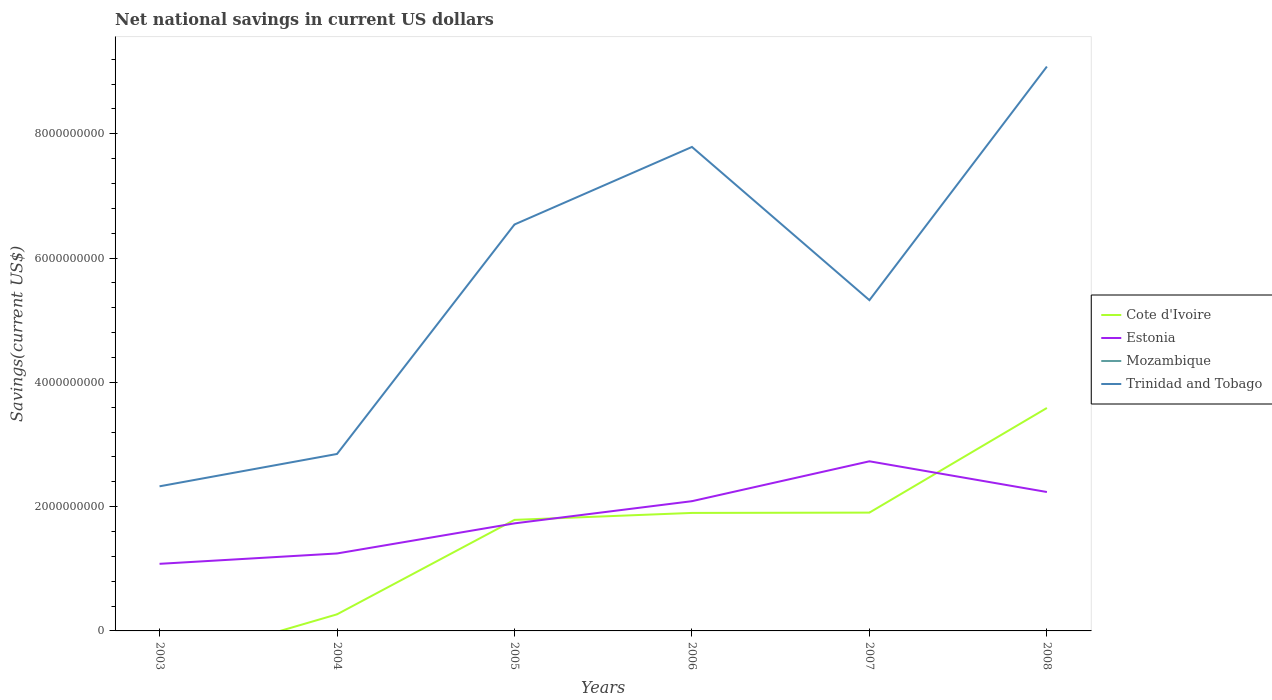How many different coloured lines are there?
Make the answer very short. 3. Does the line corresponding to Trinidad and Tobago intersect with the line corresponding to Cote d'Ivoire?
Give a very brief answer. No. Is the number of lines equal to the number of legend labels?
Provide a succinct answer. No. Across all years, what is the maximum net national savings in Mozambique?
Offer a very short reply. 0. What is the total net national savings in Cote d'Ivoire in the graph?
Ensure brevity in your answer.  -1.63e+09. What is the difference between the highest and the second highest net national savings in Estonia?
Provide a short and direct response. 1.65e+09. Is the net national savings in Trinidad and Tobago strictly greater than the net national savings in Mozambique over the years?
Make the answer very short. No. How many years are there in the graph?
Keep it short and to the point. 6. What is the difference between two consecutive major ticks on the Y-axis?
Keep it short and to the point. 2.00e+09. Does the graph contain grids?
Provide a short and direct response. No. Where does the legend appear in the graph?
Offer a very short reply. Center right. How many legend labels are there?
Give a very brief answer. 4. How are the legend labels stacked?
Provide a short and direct response. Vertical. What is the title of the graph?
Your answer should be very brief. Net national savings in current US dollars. What is the label or title of the Y-axis?
Provide a succinct answer. Savings(current US$). What is the Savings(current US$) of Estonia in 2003?
Ensure brevity in your answer.  1.08e+09. What is the Savings(current US$) of Trinidad and Tobago in 2003?
Provide a succinct answer. 2.33e+09. What is the Savings(current US$) of Cote d'Ivoire in 2004?
Your answer should be very brief. 2.67e+08. What is the Savings(current US$) in Estonia in 2004?
Give a very brief answer. 1.25e+09. What is the Savings(current US$) of Trinidad and Tobago in 2004?
Keep it short and to the point. 2.85e+09. What is the Savings(current US$) of Cote d'Ivoire in 2005?
Keep it short and to the point. 1.79e+09. What is the Savings(current US$) in Estonia in 2005?
Make the answer very short. 1.73e+09. What is the Savings(current US$) in Trinidad and Tobago in 2005?
Offer a very short reply. 6.54e+09. What is the Savings(current US$) in Cote d'Ivoire in 2006?
Make the answer very short. 1.90e+09. What is the Savings(current US$) of Estonia in 2006?
Provide a succinct answer. 2.09e+09. What is the Savings(current US$) of Mozambique in 2006?
Your answer should be very brief. 0. What is the Savings(current US$) of Trinidad and Tobago in 2006?
Your answer should be very brief. 7.79e+09. What is the Savings(current US$) of Cote d'Ivoire in 2007?
Ensure brevity in your answer.  1.90e+09. What is the Savings(current US$) in Estonia in 2007?
Your answer should be compact. 2.73e+09. What is the Savings(current US$) in Trinidad and Tobago in 2007?
Your response must be concise. 5.32e+09. What is the Savings(current US$) in Cote d'Ivoire in 2008?
Offer a very short reply. 3.59e+09. What is the Savings(current US$) in Estonia in 2008?
Offer a very short reply. 2.24e+09. What is the Savings(current US$) of Mozambique in 2008?
Your answer should be compact. 0. What is the Savings(current US$) of Trinidad and Tobago in 2008?
Give a very brief answer. 9.08e+09. Across all years, what is the maximum Savings(current US$) of Cote d'Ivoire?
Your response must be concise. 3.59e+09. Across all years, what is the maximum Savings(current US$) of Estonia?
Provide a short and direct response. 2.73e+09. Across all years, what is the maximum Savings(current US$) of Trinidad and Tobago?
Offer a very short reply. 9.08e+09. Across all years, what is the minimum Savings(current US$) in Cote d'Ivoire?
Ensure brevity in your answer.  0. Across all years, what is the minimum Savings(current US$) of Estonia?
Your answer should be compact. 1.08e+09. Across all years, what is the minimum Savings(current US$) in Trinidad and Tobago?
Provide a short and direct response. 2.33e+09. What is the total Savings(current US$) in Cote d'Ivoire in the graph?
Offer a very short reply. 9.45e+09. What is the total Savings(current US$) in Estonia in the graph?
Your answer should be compact. 1.11e+1. What is the total Savings(current US$) of Trinidad and Tobago in the graph?
Ensure brevity in your answer.  3.39e+1. What is the difference between the Savings(current US$) of Estonia in 2003 and that in 2004?
Make the answer very short. -1.67e+08. What is the difference between the Savings(current US$) of Trinidad and Tobago in 2003 and that in 2004?
Offer a terse response. -5.20e+08. What is the difference between the Savings(current US$) in Estonia in 2003 and that in 2005?
Give a very brief answer. -6.51e+08. What is the difference between the Savings(current US$) of Trinidad and Tobago in 2003 and that in 2005?
Your response must be concise. -4.21e+09. What is the difference between the Savings(current US$) in Estonia in 2003 and that in 2006?
Provide a short and direct response. -1.01e+09. What is the difference between the Savings(current US$) of Trinidad and Tobago in 2003 and that in 2006?
Make the answer very short. -5.46e+09. What is the difference between the Savings(current US$) of Estonia in 2003 and that in 2007?
Your response must be concise. -1.65e+09. What is the difference between the Savings(current US$) of Trinidad and Tobago in 2003 and that in 2007?
Your answer should be compact. -3.00e+09. What is the difference between the Savings(current US$) of Estonia in 2003 and that in 2008?
Offer a very short reply. -1.16e+09. What is the difference between the Savings(current US$) of Trinidad and Tobago in 2003 and that in 2008?
Ensure brevity in your answer.  -6.76e+09. What is the difference between the Savings(current US$) of Cote d'Ivoire in 2004 and that in 2005?
Your answer should be compact. -1.52e+09. What is the difference between the Savings(current US$) in Estonia in 2004 and that in 2005?
Offer a very short reply. -4.84e+08. What is the difference between the Savings(current US$) in Trinidad and Tobago in 2004 and that in 2005?
Keep it short and to the point. -3.69e+09. What is the difference between the Savings(current US$) of Cote d'Ivoire in 2004 and that in 2006?
Provide a succinct answer. -1.63e+09. What is the difference between the Savings(current US$) of Estonia in 2004 and that in 2006?
Ensure brevity in your answer.  -8.41e+08. What is the difference between the Savings(current US$) of Trinidad and Tobago in 2004 and that in 2006?
Your response must be concise. -4.94e+09. What is the difference between the Savings(current US$) in Cote d'Ivoire in 2004 and that in 2007?
Give a very brief answer. -1.64e+09. What is the difference between the Savings(current US$) in Estonia in 2004 and that in 2007?
Your answer should be very brief. -1.48e+09. What is the difference between the Savings(current US$) in Trinidad and Tobago in 2004 and that in 2007?
Make the answer very short. -2.48e+09. What is the difference between the Savings(current US$) in Cote d'Ivoire in 2004 and that in 2008?
Offer a very short reply. -3.32e+09. What is the difference between the Savings(current US$) in Estonia in 2004 and that in 2008?
Make the answer very short. -9.89e+08. What is the difference between the Savings(current US$) in Trinidad and Tobago in 2004 and that in 2008?
Offer a very short reply. -6.23e+09. What is the difference between the Savings(current US$) in Cote d'Ivoire in 2005 and that in 2006?
Your response must be concise. -1.12e+08. What is the difference between the Savings(current US$) of Estonia in 2005 and that in 2006?
Your answer should be compact. -3.57e+08. What is the difference between the Savings(current US$) in Trinidad and Tobago in 2005 and that in 2006?
Keep it short and to the point. -1.25e+09. What is the difference between the Savings(current US$) of Cote d'Ivoire in 2005 and that in 2007?
Provide a short and direct response. -1.17e+08. What is the difference between the Savings(current US$) of Estonia in 2005 and that in 2007?
Make the answer very short. -9.99e+08. What is the difference between the Savings(current US$) in Trinidad and Tobago in 2005 and that in 2007?
Ensure brevity in your answer.  1.22e+09. What is the difference between the Savings(current US$) in Cote d'Ivoire in 2005 and that in 2008?
Provide a succinct answer. -1.80e+09. What is the difference between the Savings(current US$) of Estonia in 2005 and that in 2008?
Offer a very short reply. -5.05e+08. What is the difference between the Savings(current US$) in Trinidad and Tobago in 2005 and that in 2008?
Offer a terse response. -2.54e+09. What is the difference between the Savings(current US$) of Cote d'Ivoire in 2006 and that in 2007?
Give a very brief answer. -4.95e+06. What is the difference between the Savings(current US$) in Estonia in 2006 and that in 2007?
Offer a very short reply. -6.42e+08. What is the difference between the Savings(current US$) in Trinidad and Tobago in 2006 and that in 2007?
Give a very brief answer. 2.47e+09. What is the difference between the Savings(current US$) in Cote d'Ivoire in 2006 and that in 2008?
Offer a terse response. -1.69e+09. What is the difference between the Savings(current US$) in Estonia in 2006 and that in 2008?
Make the answer very short. -1.48e+08. What is the difference between the Savings(current US$) in Trinidad and Tobago in 2006 and that in 2008?
Ensure brevity in your answer.  -1.29e+09. What is the difference between the Savings(current US$) of Cote d'Ivoire in 2007 and that in 2008?
Your answer should be compact. -1.68e+09. What is the difference between the Savings(current US$) in Estonia in 2007 and that in 2008?
Your answer should be very brief. 4.94e+08. What is the difference between the Savings(current US$) in Trinidad and Tobago in 2007 and that in 2008?
Keep it short and to the point. -3.76e+09. What is the difference between the Savings(current US$) in Estonia in 2003 and the Savings(current US$) in Trinidad and Tobago in 2004?
Give a very brief answer. -1.77e+09. What is the difference between the Savings(current US$) of Estonia in 2003 and the Savings(current US$) of Trinidad and Tobago in 2005?
Give a very brief answer. -5.46e+09. What is the difference between the Savings(current US$) in Estonia in 2003 and the Savings(current US$) in Trinidad and Tobago in 2006?
Your answer should be compact. -6.71e+09. What is the difference between the Savings(current US$) of Estonia in 2003 and the Savings(current US$) of Trinidad and Tobago in 2007?
Your answer should be very brief. -4.24e+09. What is the difference between the Savings(current US$) in Estonia in 2003 and the Savings(current US$) in Trinidad and Tobago in 2008?
Your answer should be very brief. -8.00e+09. What is the difference between the Savings(current US$) of Cote d'Ivoire in 2004 and the Savings(current US$) of Estonia in 2005?
Offer a very short reply. -1.46e+09. What is the difference between the Savings(current US$) in Cote d'Ivoire in 2004 and the Savings(current US$) in Trinidad and Tobago in 2005?
Give a very brief answer. -6.27e+09. What is the difference between the Savings(current US$) in Estonia in 2004 and the Savings(current US$) in Trinidad and Tobago in 2005?
Provide a short and direct response. -5.29e+09. What is the difference between the Savings(current US$) of Cote d'Ivoire in 2004 and the Savings(current US$) of Estonia in 2006?
Offer a terse response. -1.82e+09. What is the difference between the Savings(current US$) of Cote d'Ivoire in 2004 and the Savings(current US$) of Trinidad and Tobago in 2006?
Provide a succinct answer. -7.52e+09. What is the difference between the Savings(current US$) of Estonia in 2004 and the Savings(current US$) of Trinidad and Tobago in 2006?
Your answer should be very brief. -6.54e+09. What is the difference between the Savings(current US$) of Cote d'Ivoire in 2004 and the Savings(current US$) of Estonia in 2007?
Your response must be concise. -2.46e+09. What is the difference between the Savings(current US$) of Cote d'Ivoire in 2004 and the Savings(current US$) of Trinidad and Tobago in 2007?
Offer a terse response. -5.06e+09. What is the difference between the Savings(current US$) in Estonia in 2004 and the Savings(current US$) in Trinidad and Tobago in 2007?
Offer a terse response. -4.08e+09. What is the difference between the Savings(current US$) in Cote d'Ivoire in 2004 and the Savings(current US$) in Estonia in 2008?
Provide a succinct answer. -1.97e+09. What is the difference between the Savings(current US$) in Cote d'Ivoire in 2004 and the Savings(current US$) in Trinidad and Tobago in 2008?
Provide a short and direct response. -8.82e+09. What is the difference between the Savings(current US$) in Estonia in 2004 and the Savings(current US$) in Trinidad and Tobago in 2008?
Offer a very short reply. -7.84e+09. What is the difference between the Savings(current US$) of Cote d'Ivoire in 2005 and the Savings(current US$) of Estonia in 2006?
Offer a very short reply. -3.01e+08. What is the difference between the Savings(current US$) in Cote d'Ivoire in 2005 and the Savings(current US$) in Trinidad and Tobago in 2006?
Make the answer very short. -6.00e+09. What is the difference between the Savings(current US$) of Estonia in 2005 and the Savings(current US$) of Trinidad and Tobago in 2006?
Your response must be concise. -6.06e+09. What is the difference between the Savings(current US$) in Cote d'Ivoire in 2005 and the Savings(current US$) in Estonia in 2007?
Ensure brevity in your answer.  -9.43e+08. What is the difference between the Savings(current US$) in Cote d'Ivoire in 2005 and the Savings(current US$) in Trinidad and Tobago in 2007?
Provide a succinct answer. -3.54e+09. What is the difference between the Savings(current US$) of Estonia in 2005 and the Savings(current US$) of Trinidad and Tobago in 2007?
Offer a very short reply. -3.59e+09. What is the difference between the Savings(current US$) in Cote d'Ivoire in 2005 and the Savings(current US$) in Estonia in 2008?
Give a very brief answer. -4.48e+08. What is the difference between the Savings(current US$) in Cote d'Ivoire in 2005 and the Savings(current US$) in Trinidad and Tobago in 2008?
Your answer should be very brief. -7.30e+09. What is the difference between the Savings(current US$) in Estonia in 2005 and the Savings(current US$) in Trinidad and Tobago in 2008?
Give a very brief answer. -7.35e+09. What is the difference between the Savings(current US$) of Cote d'Ivoire in 2006 and the Savings(current US$) of Estonia in 2007?
Keep it short and to the point. -8.31e+08. What is the difference between the Savings(current US$) of Cote d'Ivoire in 2006 and the Savings(current US$) of Trinidad and Tobago in 2007?
Ensure brevity in your answer.  -3.42e+09. What is the difference between the Savings(current US$) of Estonia in 2006 and the Savings(current US$) of Trinidad and Tobago in 2007?
Your answer should be very brief. -3.24e+09. What is the difference between the Savings(current US$) of Cote d'Ivoire in 2006 and the Savings(current US$) of Estonia in 2008?
Your answer should be compact. -3.37e+08. What is the difference between the Savings(current US$) in Cote d'Ivoire in 2006 and the Savings(current US$) in Trinidad and Tobago in 2008?
Ensure brevity in your answer.  -7.18e+09. What is the difference between the Savings(current US$) in Estonia in 2006 and the Savings(current US$) in Trinidad and Tobago in 2008?
Provide a short and direct response. -6.99e+09. What is the difference between the Savings(current US$) of Cote d'Ivoire in 2007 and the Savings(current US$) of Estonia in 2008?
Your response must be concise. -3.32e+08. What is the difference between the Savings(current US$) of Cote d'Ivoire in 2007 and the Savings(current US$) of Trinidad and Tobago in 2008?
Keep it short and to the point. -7.18e+09. What is the difference between the Savings(current US$) of Estonia in 2007 and the Savings(current US$) of Trinidad and Tobago in 2008?
Your response must be concise. -6.35e+09. What is the average Savings(current US$) of Cote d'Ivoire per year?
Give a very brief answer. 1.57e+09. What is the average Savings(current US$) of Estonia per year?
Give a very brief answer. 1.85e+09. What is the average Savings(current US$) of Trinidad and Tobago per year?
Provide a short and direct response. 5.65e+09. In the year 2003, what is the difference between the Savings(current US$) in Estonia and Savings(current US$) in Trinidad and Tobago?
Your response must be concise. -1.25e+09. In the year 2004, what is the difference between the Savings(current US$) in Cote d'Ivoire and Savings(current US$) in Estonia?
Give a very brief answer. -9.80e+08. In the year 2004, what is the difference between the Savings(current US$) in Cote d'Ivoire and Savings(current US$) in Trinidad and Tobago?
Your response must be concise. -2.58e+09. In the year 2004, what is the difference between the Savings(current US$) of Estonia and Savings(current US$) of Trinidad and Tobago?
Your answer should be very brief. -1.60e+09. In the year 2005, what is the difference between the Savings(current US$) in Cote d'Ivoire and Savings(current US$) in Estonia?
Give a very brief answer. 5.63e+07. In the year 2005, what is the difference between the Savings(current US$) of Cote d'Ivoire and Savings(current US$) of Trinidad and Tobago?
Your answer should be compact. -4.75e+09. In the year 2005, what is the difference between the Savings(current US$) in Estonia and Savings(current US$) in Trinidad and Tobago?
Offer a very short reply. -4.81e+09. In the year 2006, what is the difference between the Savings(current US$) of Cote d'Ivoire and Savings(current US$) of Estonia?
Ensure brevity in your answer.  -1.89e+08. In the year 2006, what is the difference between the Savings(current US$) of Cote d'Ivoire and Savings(current US$) of Trinidad and Tobago?
Keep it short and to the point. -5.89e+09. In the year 2006, what is the difference between the Savings(current US$) in Estonia and Savings(current US$) in Trinidad and Tobago?
Make the answer very short. -5.70e+09. In the year 2007, what is the difference between the Savings(current US$) in Cote d'Ivoire and Savings(current US$) in Estonia?
Offer a terse response. -8.26e+08. In the year 2007, what is the difference between the Savings(current US$) of Cote d'Ivoire and Savings(current US$) of Trinidad and Tobago?
Provide a short and direct response. -3.42e+09. In the year 2007, what is the difference between the Savings(current US$) of Estonia and Savings(current US$) of Trinidad and Tobago?
Offer a terse response. -2.59e+09. In the year 2008, what is the difference between the Savings(current US$) in Cote d'Ivoire and Savings(current US$) in Estonia?
Provide a succinct answer. 1.35e+09. In the year 2008, what is the difference between the Savings(current US$) of Cote d'Ivoire and Savings(current US$) of Trinidad and Tobago?
Your answer should be compact. -5.49e+09. In the year 2008, what is the difference between the Savings(current US$) in Estonia and Savings(current US$) in Trinidad and Tobago?
Your answer should be very brief. -6.85e+09. What is the ratio of the Savings(current US$) of Estonia in 2003 to that in 2004?
Your answer should be very brief. 0.87. What is the ratio of the Savings(current US$) in Trinidad and Tobago in 2003 to that in 2004?
Make the answer very short. 0.82. What is the ratio of the Savings(current US$) in Estonia in 2003 to that in 2005?
Provide a succinct answer. 0.62. What is the ratio of the Savings(current US$) in Trinidad and Tobago in 2003 to that in 2005?
Offer a terse response. 0.36. What is the ratio of the Savings(current US$) of Estonia in 2003 to that in 2006?
Make the answer very short. 0.52. What is the ratio of the Savings(current US$) of Trinidad and Tobago in 2003 to that in 2006?
Provide a succinct answer. 0.3. What is the ratio of the Savings(current US$) of Estonia in 2003 to that in 2007?
Provide a short and direct response. 0.4. What is the ratio of the Savings(current US$) of Trinidad and Tobago in 2003 to that in 2007?
Keep it short and to the point. 0.44. What is the ratio of the Savings(current US$) of Estonia in 2003 to that in 2008?
Make the answer very short. 0.48. What is the ratio of the Savings(current US$) of Trinidad and Tobago in 2003 to that in 2008?
Make the answer very short. 0.26. What is the ratio of the Savings(current US$) of Cote d'Ivoire in 2004 to that in 2005?
Ensure brevity in your answer.  0.15. What is the ratio of the Savings(current US$) of Estonia in 2004 to that in 2005?
Make the answer very short. 0.72. What is the ratio of the Savings(current US$) of Trinidad and Tobago in 2004 to that in 2005?
Offer a very short reply. 0.44. What is the ratio of the Savings(current US$) of Cote d'Ivoire in 2004 to that in 2006?
Give a very brief answer. 0.14. What is the ratio of the Savings(current US$) of Estonia in 2004 to that in 2006?
Offer a very short reply. 0.6. What is the ratio of the Savings(current US$) of Trinidad and Tobago in 2004 to that in 2006?
Ensure brevity in your answer.  0.37. What is the ratio of the Savings(current US$) in Cote d'Ivoire in 2004 to that in 2007?
Your answer should be compact. 0.14. What is the ratio of the Savings(current US$) in Estonia in 2004 to that in 2007?
Your answer should be very brief. 0.46. What is the ratio of the Savings(current US$) in Trinidad and Tobago in 2004 to that in 2007?
Provide a short and direct response. 0.54. What is the ratio of the Savings(current US$) in Cote d'Ivoire in 2004 to that in 2008?
Keep it short and to the point. 0.07. What is the ratio of the Savings(current US$) in Estonia in 2004 to that in 2008?
Your response must be concise. 0.56. What is the ratio of the Savings(current US$) of Trinidad and Tobago in 2004 to that in 2008?
Give a very brief answer. 0.31. What is the ratio of the Savings(current US$) in Cote d'Ivoire in 2005 to that in 2006?
Offer a very short reply. 0.94. What is the ratio of the Savings(current US$) of Estonia in 2005 to that in 2006?
Provide a short and direct response. 0.83. What is the ratio of the Savings(current US$) of Trinidad and Tobago in 2005 to that in 2006?
Give a very brief answer. 0.84. What is the ratio of the Savings(current US$) in Cote d'Ivoire in 2005 to that in 2007?
Your answer should be very brief. 0.94. What is the ratio of the Savings(current US$) of Estonia in 2005 to that in 2007?
Provide a succinct answer. 0.63. What is the ratio of the Savings(current US$) of Trinidad and Tobago in 2005 to that in 2007?
Offer a very short reply. 1.23. What is the ratio of the Savings(current US$) in Cote d'Ivoire in 2005 to that in 2008?
Your answer should be very brief. 0.5. What is the ratio of the Savings(current US$) of Estonia in 2005 to that in 2008?
Your response must be concise. 0.77. What is the ratio of the Savings(current US$) in Trinidad and Tobago in 2005 to that in 2008?
Offer a terse response. 0.72. What is the ratio of the Savings(current US$) of Estonia in 2006 to that in 2007?
Keep it short and to the point. 0.76. What is the ratio of the Savings(current US$) in Trinidad and Tobago in 2006 to that in 2007?
Provide a succinct answer. 1.46. What is the ratio of the Savings(current US$) in Cote d'Ivoire in 2006 to that in 2008?
Give a very brief answer. 0.53. What is the ratio of the Savings(current US$) of Estonia in 2006 to that in 2008?
Ensure brevity in your answer.  0.93. What is the ratio of the Savings(current US$) of Trinidad and Tobago in 2006 to that in 2008?
Provide a short and direct response. 0.86. What is the ratio of the Savings(current US$) of Cote d'Ivoire in 2007 to that in 2008?
Offer a terse response. 0.53. What is the ratio of the Savings(current US$) of Estonia in 2007 to that in 2008?
Your answer should be compact. 1.22. What is the ratio of the Savings(current US$) in Trinidad and Tobago in 2007 to that in 2008?
Make the answer very short. 0.59. What is the difference between the highest and the second highest Savings(current US$) of Cote d'Ivoire?
Give a very brief answer. 1.68e+09. What is the difference between the highest and the second highest Savings(current US$) in Estonia?
Your answer should be very brief. 4.94e+08. What is the difference between the highest and the second highest Savings(current US$) in Trinidad and Tobago?
Keep it short and to the point. 1.29e+09. What is the difference between the highest and the lowest Savings(current US$) of Cote d'Ivoire?
Provide a short and direct response. 3.59e+09. What is the difference between the highest and the lowest Savings(current US$) in Estonia?
Make the answer very short. 1.65e+09. What is the difference between the highest and the lowest Savings(current US$) in Trinidad and Tobago?
Make the answer very short. 6.76e+09. 